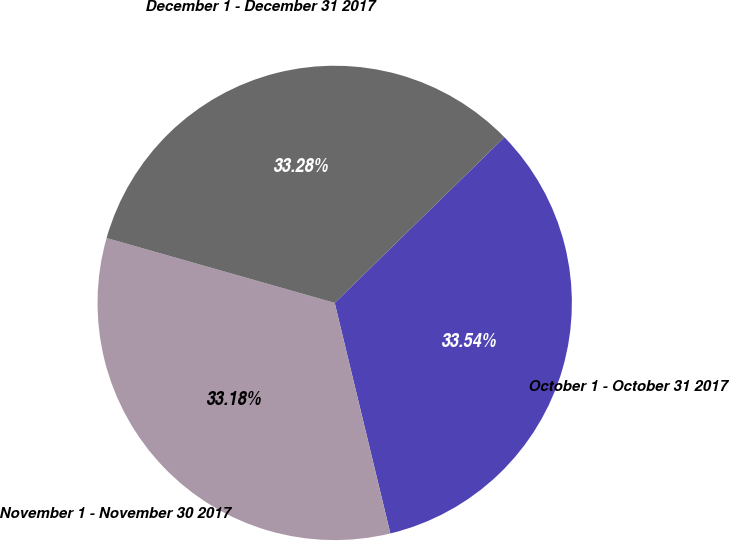Convert chart. <chart><loc_0><loc_0><loc_500><loc_500><pie_chart><fcel>October 1 - October 31 2017<fcel>November 1 - November 30 2017<fcel>December 1 - December 31 2017<nl><fcel>33.54%<fcel>33.18%<fcel>33.28%<nl></chart> 